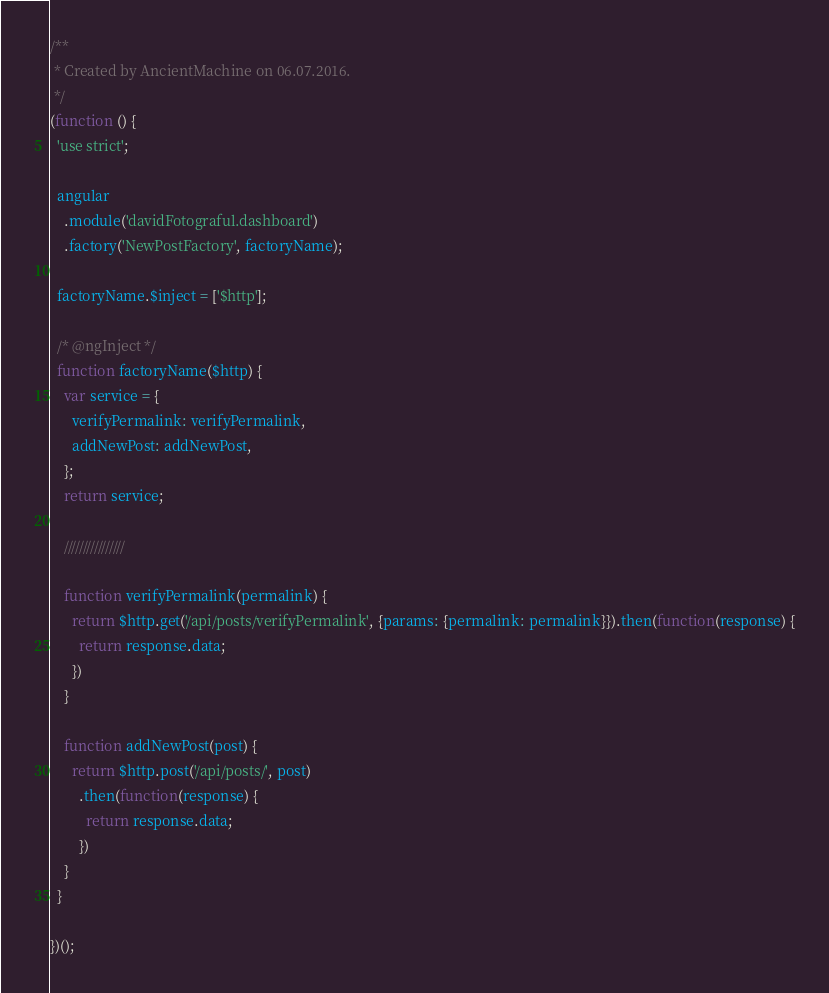<code> <loc_0><loc_0><loc_500><loc_500><_JavaScript_>/**
 * Created by AncientMachine on 06.07.2016.
 */
(function () {
  'use strict';

  angular
    .module('davidFotograful.dashboard')
    .factory('NewPostFactory', factoryName);

  factoryName.$inject = ['$http'];

  /* @ngInject */
  function factoryName($http) {
    var service = {
      verifyPermalink: verifyPermalink,
      addNewPost: addNewPost,
    };
    return service;

    ////////////////

    function verifyPermalink(permalink) {
      return $http.get('/api/posts/verifyPermalink', {params: {permalink: permalink}}).then(function(response) {
        return response.data;
      })
    }

    function addNewPost(post) {
      return $http.post('/api/posts/', post)
        .then(function(response) {
          return response.data;
        })
    }
  }

})();
</code> 